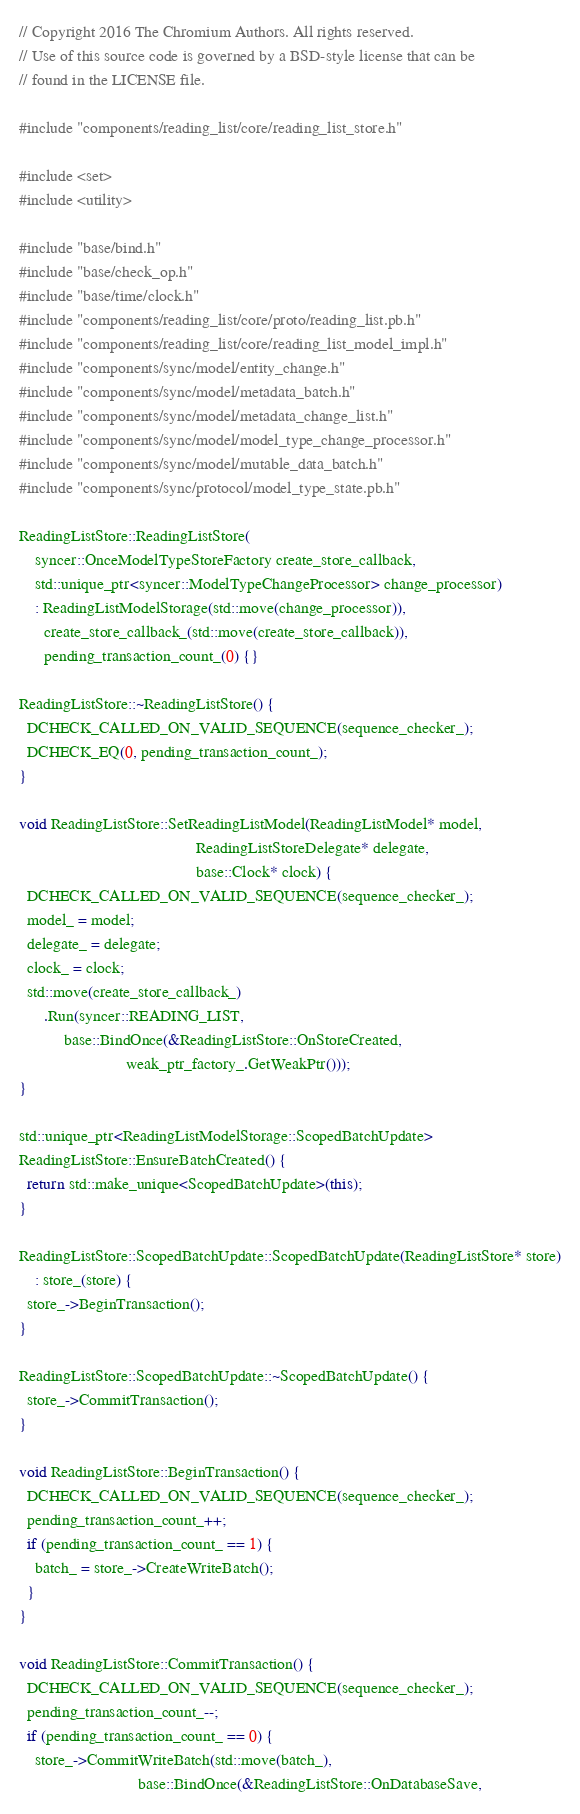<code> <loc_0><loc_0><loc_500><loc_500><_C++_>// Copyright 2016 The Chromium Authors. All rights reserved.
// Use of this source code is governed by a BSD-style license that can be
// found in the LICENSE file.

#include "components/reading_list/core/reading_list_store.h"

#include <set>
#include <utility>

#include "base/bind.h"
#include "base/check_op.h"
#include "base/time/clock.h"
#include "components/reading_list/core/proto/reading_list.pb.h"
#include "components/reading_list/core/reading_list_model_impl.h"
#include "components/sync/model/entity_change.h"
#include "components/sync/model/metadata_batch.h"
#include "components/sync/model/metadata_change_list.h"
#include "components/sync/model/model_type_change_processor.h"
#include "components/sync/model/mutable_data_batch.h"
#include "components/sync/protocol/model_type_state.pb.h"

ReadingListStore::ReadingListStore(
    syncer::OnceModelTypeStoreFactory create_store_callback,
    std::unique_ptr<syncer::ModelTypeChangeProcessor> change_processor)
    : ReadingListModelStorage(std::move(change_processor)),
      create_store_callback_(std::move(create_store_callback)),
      pending_transaction_count_(0) {}

ReadingListStore::~ReadingListStore() {
  DCHECK_CALLED_ON_VALID_SEQUENCE(sequence_checker_);
  DCHECK_EQ(0, pending_transaction_count_);
}

void ReadingListStore::SetReadingListModel(ReadingListModel* model,
                                           ReadingListStoreDelegate* delegate,
                                           base::Clock* clock) {
  DCHECK_CALLED_ON_VALID_SEQUENCE(sequence_checker_);
  model_ = model;
  delegate_ = delegate;
  clock_ = clock;
  std::move(create_store_callback_)
      .Run(syncer::READING_LIST,
           base::BindOnce(&ReadingListStore::OnStoreCreated,
                          weak_ptr_factory_.GetWeakPtr()));
}

std::unique_ptr<ReadingListModelStorage::ScopedBatchUpdate>
ReadingListStore::EnsureBatchCreated() {
  return std::make_unique<ScopedBatchUpdate>(this);
}

ReadingListStore::ScopedBatchUpdate::ScopedBatchUpdate(ReadingListStore* store)
    : store_(store) {
  store_->BeginTransaction();
}

ReadingListStore::ScopedBatchUpdate::~ScopedBatchUpdate() {
  store_->CommitTransaction();
}

void ReadingListStore::BeginTransaction() {
  DCHECK_CALLED_ON_VALID_SEQUENCE(sequence_checker_);
  pending_transaction_count_++;
  if (pending_transaction_count_ == 1) {
    batch_ = store_->CreateWriteBatch();
  }
}

void ReadingListStore::CommitTransaction() {
  DCHECK_CALLED_ON_VALID_SEQUENCE(sequence_checker_);
  pending_transaction_count_--;
  if (pending_transaction_count_ == 0) {
    store_->CommitWriteBatch(std::move(batch_),
                             base::BindOnce(&ReadingListStore::OnDatabaseSave,</code> 